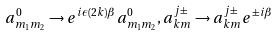<formula> <loc_0><loc_0><loc_500><loc_500>a _ { m _ { 1 } m _ { 2 } } ^ { 0 } \to e ^ { i \epsilon ( 2 k ) \beta } a _ { m _ { 1 } m _ { 2 } } ^ { 0 } , a _ { k m } ^ { j \pm } \to a _ { k m } ^ { j \pm } e ^ { \pm i \beta }</formula> 